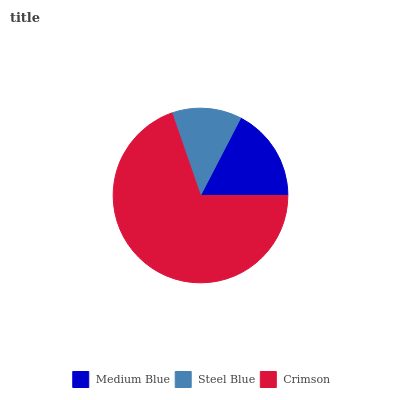Is Steel Blue the minimum?
Answer yes or no. Yes. Is Crimson the maximum?
Answer yes or no. Yes. Is Crimson the minimum?
Answer yes or no. No. Is Steel Blue the maximum?
Answer yes or no. No. Is Crimson greater than Steel Blue?
Answer yes or no. Yes. Is Steel Blue less than Crimson?
Answer yes or no. Yes. Is Steel Blue greater than Crimson?
Answer yes or no. No. Is Crimson less than Steel Blue?
Answer yes or no. No. Is Medium Blue the high median?
Answer yes or no. Yes. Is Medium Blue the low median?
Answer yes or no. Yes. Is Steel Blue the high median?
Answer yes or no. No. Is Steel Blue the low median?
Answer yes or no. No. 